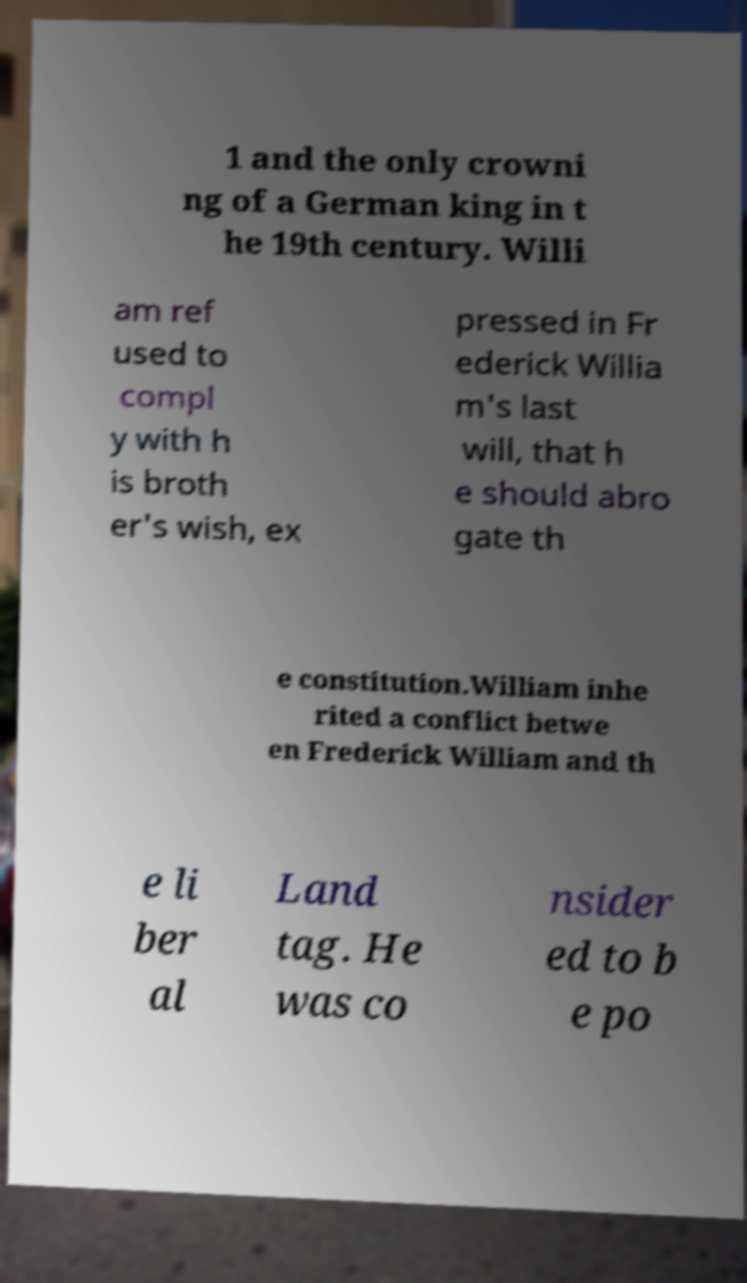What messages or text are displayed in this image? I need them in a readable, typed format. 1 and the only crowni ng of a German king in t he 19th century. Willi am ref used to compl y with h is broth er's wish, ex pressed in Fr ederick Willia m's last will, that h e should abro gate th e constitution.William inhe rited a conflict betwe en Frederick William and th e li ber al Land tag. He was co nsider ed to b e po 